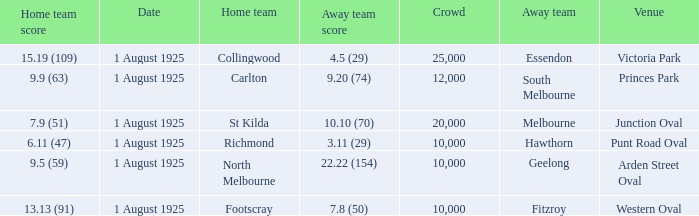Which game with a home team score of 13.13 (91) had the highest attendance? 10000.0. 